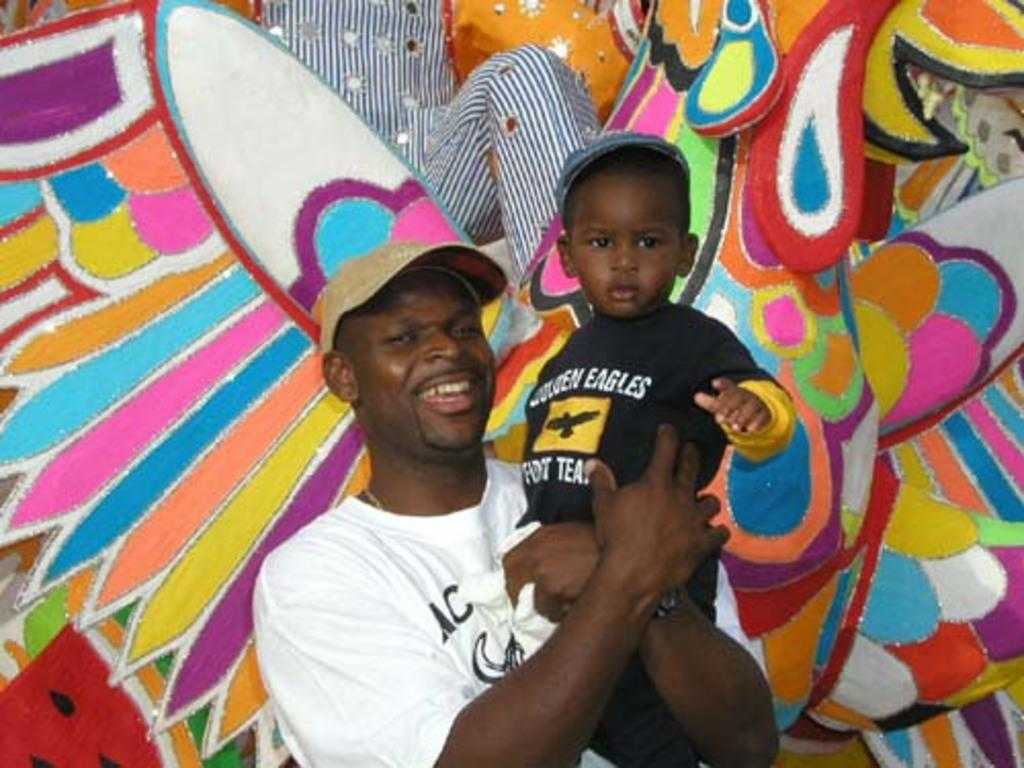<image>
Write a terse but informative summary of the picture. A small child with a golden eagles shirt is held by a man. 